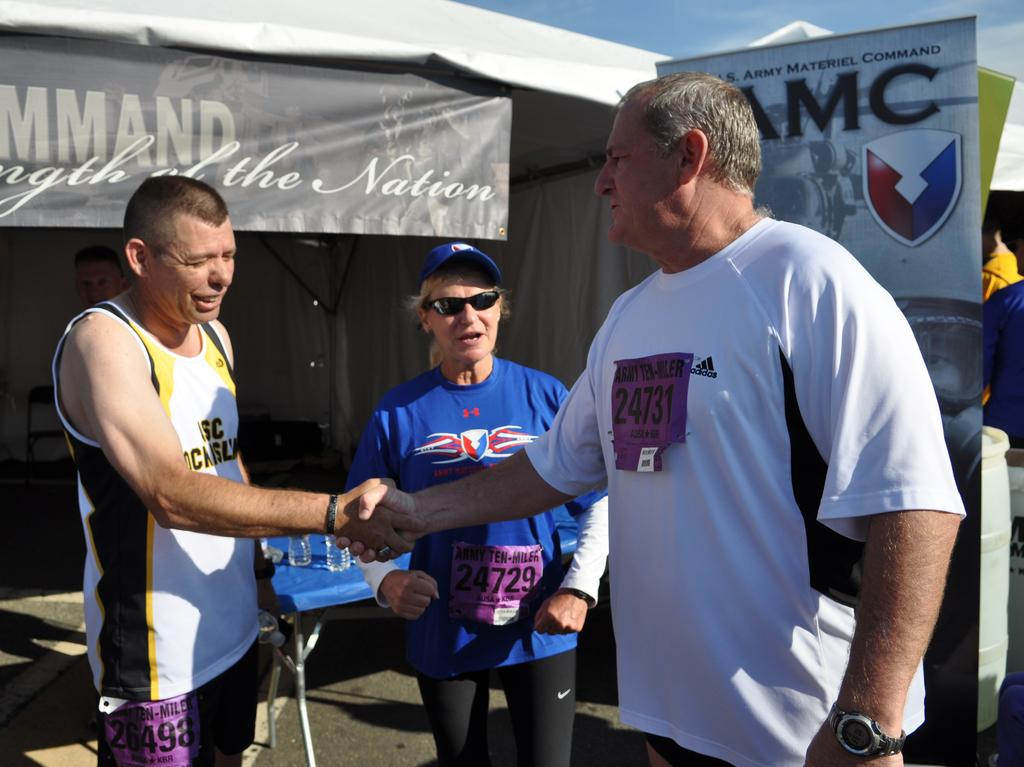<image>
Write a terse but informative summary of the picture. Two men shake hands while talking to a woman with a sign for U.S. Army Materiel Command 